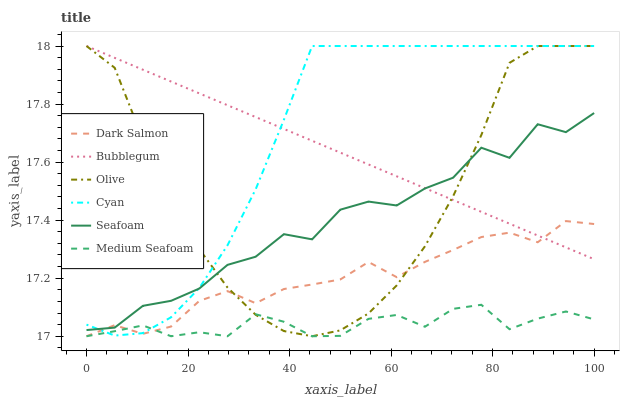Does Medium Seafoam have the minimum area under the curve?
Answer yes or no. Yes. Does Cyan have the maximum area under the curve?
Answer yes or no. Yes. Does Bubblegum have the minimum area under the curve?
Answer yes or no. No. Does Bubblegum have the maximum area under the curve?
Answer yes or no. No. Is Bubblegum the smoothest?
Answer yes or no. Yes. Is Seafoam the roughest?
Answer yes or no. Yes. Is Seafoam the smoothest?
Answer yes or no. No. Is Bubblegum the roughest?
Answer yes or no. No. Does Seafoam have the lowest value?
Answer yes or no. No. Does Cyan have the highest value?
Answer yes or no. Yes. Does Seafoam have the highest value?
Answer yes or no. No. Is Medium Seafoam less than Seafoam?
Answer yes or no. Yes. Is Seafoam greater than Medium Seafoam?
Answer yes or no. Yes. Does Dark Salmon intersect Medium Seafoam?
Answer yes or no. Yes. Is Dark Salmon less than Medium Seafoam?
Answer yes or no. No. Is Dark Salmon greater than Medium Seafoam?
Answer yes or no. No. Does Medium Seafoam intersect Seafoam?
Answer yes or no. No. 